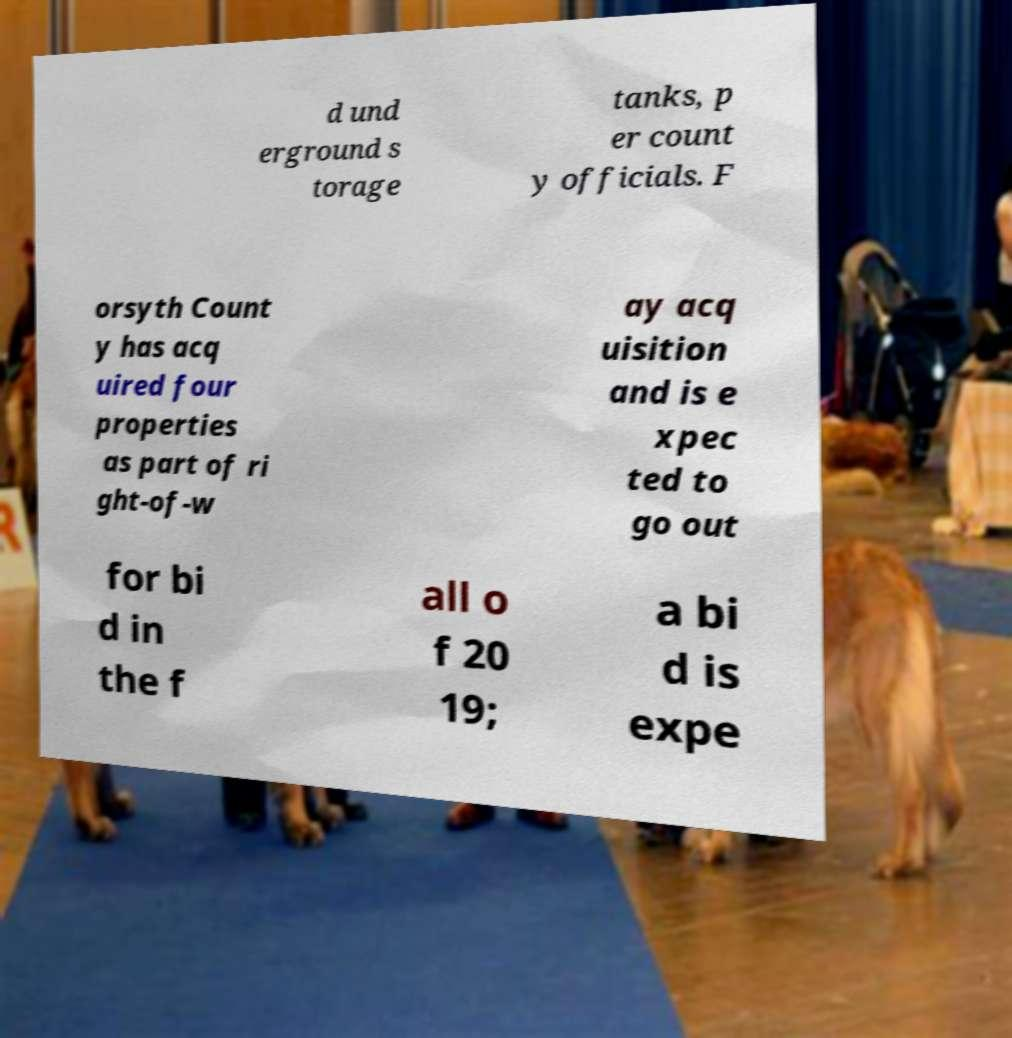There's text embedded in this image that I need extracted. Can you transcribe it verbatim? d und erground s torage tanks, p er count y officials. F orsyth Count y has acq uired four properties as part of ri ght-of-w ay acq uisition and is e xpec ted to go out for bi d in the f all o f 20 19; a bi d is expe 